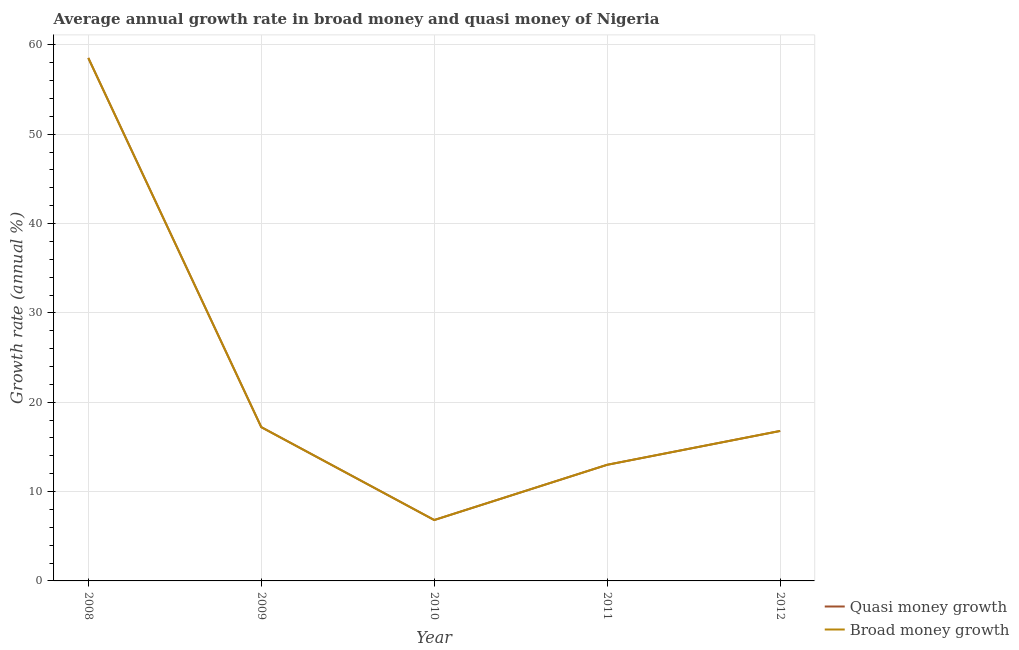How many different coloured lines are there?
Your answer should be very brief. 2. Is the number of lines equal to the number of legend labels?
Your response must be concise. Yes. What is the annual growth rate in broad money in 2008?
Ensure brevity in your answer.  58.53. Across all years, what is the maximum annual growth rate in quasi money?
Offer a terse response. 58.53. Across all years, what is the minimum annual growth rate in broad money?
Give a very brief answer. 6.82. In which year was the annual growth rate in broad money maximum?
Offer a terse response. 2008. In which year was the annual growth rate in quasi money minimum?
Offer a very short reply. 2010. What is the total annual growth rate in broad money in the graph?
Give a very brief answer. 112.35. What is the difference between the annual growth rate in quasi money in 2008 and that in 2010?
Offer a terse response. 51.72. What is the difference between the annual growth rate in quasi money in 2010 and the annual growth rate in broad money in 2009?
Make the answer very short. -10.4. What is the average annual growth rate in broad money per year?
Your response must be concise. 22.47. In the year 2008, what is the difference between the annual growth rate in broad money and annual growth rate in quasi money?
Your response must be concise. 0. What is the ratio of the annual growth rate in quasi money in 2010 to that in 2011?
Offer a very short reply. 0.52. Is the annual growth rate in broad money in 2008 less than that in 2010?
Make the answer very short. No. What is the difference between the highest and the second highest annual growth rate in quasi money?
Your answer should be very brief. 41.32. What is the difference between the highest and the lowest annual growth rate in broad money?
Provide a succinct answer. 51.72. In how many years, is the annual growth rate in broad money greater than the average annual growth rate in broad money taken over all years?
Offer a terse response. 1. Does the annual growth rate in broad money monotonically increase over the years?
Offer a terse response. No. Is the annual growth rate in quasi money strictly greater than the annual growth rate in broad money over the years?
Your answer should be compact. No. How many lines are there?
Ensure brevity in your answer.  2. What is the difference between two consecutive major ticks on the Y-axis?
Your response must be concise. 10. Does the graph contain grids?
Keep it short and to the point. Yes. Where does the legend appear in the graph?
Offer a very short reply. Bottom right. What is the title of the graph?
Make the answer very short. Average annual growth rate in broad money and quasi money of Nigeria. What is the label or title of the X-axis?
Keep it short and to the point. Year. What is the label or title of the Y-axis?
Give a very brief answer. Growth rate (annual %). What is the Growth rate (annual %) in Quasi money growth in 2008?
Your answer should be very brief. 58.53. What is the Growth rate (annual %) of Broad money growth in 2008?
Provide a succinct answer. 58.53. What is the Growth rate (annual %) in Quasi money growth in 2009?
Offer a terse response. 17.21. What is the Growth rate (annual %) of Broad money growth in 2009?
Ensure brevity in your answer.  17.21. What is the Growth rate (annual %) of Quasi money growth in 2010?
Your answer should be very brief. 6.82. What is the Growth rate (annual %) in Broad money growth in 2010?
Provide a succinct answer. 6.82. What is the Growth rate (annual %) in Quasi money growth in 2011?
Make the answer very short. 13. What is the Growth rate (annual %) in Broad money growth in 2011?
Ensure brevity in your answer.  13. What is the Growth rate (annual %) in Quasi money growth in 2012?
Offer a terse response. 16.79. What is the Growth rate (annual %) in Broad money growth in 2012?
Offer a very short reply. 16.79. Across all years, what is the maximum Growth rate (annual %) in Quasi money growth?
Give a very brief answer. 58.53. Across all years, what is the maximum Growth rate (annual %) of Broad money growth?
Ensure brevity in your answer.  58.53. Across all years, what is the minimum Growth rate (annual %) in Quasi money growth?
Ensure brevity in your answer.  6.82. Across all years, what is the minimum Growth rate (annual %) in Broad money growth?
Provide a short and direct response. 6.82. What is the total Growth rate (annual %) of Quasi money growth in the graph?
Keep it short and to the point. 112.35. What is the total Growth rate (annual %) of Broad money growth in the graph?
Provide a short and direct response. 112.35. What is the difference between the Growth rate (annual %) of Quasi money growth in 2008 and that in 2009?
Your answer should be very brief. 41.32. What is the difference between the Growth rate (annual %) in Broad money growth in 2008 and that in 2009?
Your response must be concise. 41.32. What is the difference between the Growth rate (annual %) of Quasi money growth in 2008 and that in 2010?
Your response must be concise. 51.72. What is the difference between the Growth rate (annual %) in Broad money growth in 2008 and that in 2010?
Give a very brief answer. 51.72. What is the difference between the Growth rate (annual %) in Quasi money growth in 2008 and that in 2011?
Your answer should be compact. 45.54. What is the difference between the Growth rate (annual %) in Broad money growth in 2008 and that in 2011?
Your answer should be compact. 45.54. What is the difference between the Growth rate (annual %) in Quasi money growth in 2008 and that in 2012?
Your response must be concise. 41.75. What is the difference between the Growth rate (annual %) of Broad money growth in 2008 and that in 2012?
Provide a succinct answer. 41.75. What is the difference between the Growth rate (annual %) in Quasi money growth in 2009 and that in 2010?
Offer a terse response. 10.4. What is the difference between the Growth rate (annual %) in Broad money growth in 2009 and that in 2010?
Keep it short and to the point. 10.4. What is the difference between the Growth rate (annual %) of Quasi money growth in 2009 and that in 2011?
Keep it short and to the point. 4.22. What is the difference between the Growth rate (annual %) in Broad money growth in 2009 and that in 2011?
Offer a terse response. 4.22. What is the difference between the Growth rate (annual %) in Quasi money growth in 2009 and that in 2012?
Keep it short and to the point. 0.43. What is the difference between the Growth rate (annual %) of Broad money growth in 2009 and that in 2012?
Offer a terse response. 0.43. What is the difference between the Growth rate (annual %) in Quasi money growth in 2010 and that in 2011?
Offer a terse response. -6.18. What is the difference between the Growth rate (annual %) in Broad money growth in 2010 and that in 2011?
Make the answer very short. -6.18. What is the difference between the Growth rate (annual %) of Quasi money growth in 2010 and that in 2012?
Offer a terse response. -9.97. What is the difference between the Growth rate (annual %) of Broad money growth in 2010 and that in 2012?
Give a very brief answer. -9.97. What is the difference between the Growth rate (annual %) in Quasi money growth in 2011 and that in 2012?
Your answer should be very brief. -3.79. What is the difference between the Growth rate (annual %) of Broad money growth in 2011 and that in 2012?
Provide a succinct answer. -3.79. What is the difference between the Growth rate (annual %) of Quasi money growth in 2008 and the Growth rate (annual %) of Broad money growth in 2009?
Your answer should be very brief. 41.32. What is the difference between the Growth rate (annual %) of Quasi money growth in 2008 and the Growth rate (annual %) of Broad money growth in 2010?
Keep it short and to the point. 51.72. What is the difference between the Growth rate (annual %) in Quasi money growth in 2008 and the Growth rate (annual %) in Broad money growth in 2011?
Keep it short and to the point. 45.54. What is the difference between the Growth rate (annual %) in Quasi money growth in 2008 and the Growth rate (annual %) in Broad money growth in 2012?
Make the answer very short. 41.75. What is the difference between the Growth rate (annual %) in Quasi money growth in 2009 and the Growth rate (annual %) in Broad money growth in 2010?
Offer a terse response. 10.4. What is the difference between the Growth rate (annual %) of Quasi money growth in 2009 and the Growth rate (annual %) of Broad money growth in 2011?
Your response must be concise. 4.22. What is the difference between the Growth rate (annual %) of Quasi money growth in 2009 and the Growth rate (annual %) of Broad money growth in 2012?
Offer a terse response. 0.43. What is the difference between the Growth rate (annual %) in Quasi money growth in 2010 and the Growth rate (annual %) in Broad money growth in 2011?
Give a very brief answer. -6.18. What is the difference between the Growth rate (annual %) in Quasi money growth in 2010 and the Growth rate (annual %) in Broad money growth in 2012?
Offer a very short reply. -9.97. What is the difference between the Growth rate (annual %) in Quasi money growth in 2011 and the Growth rate (annual %) in Broad money growth in 2012?
Keep it short and to the point. -3.79. What is the average Growth rate (annual %) of Quasi money growth per year?
Make the answer very short. 22.47. What is the average Growth rate (annual %) of Broad money growth per year?
Your response must be concise. 22.47. In the year 2008, what is the difference between the Growth rate (annual %) of Quasi money growth and Growth rate (annual %) of Broad money growth?
Provide a succinct answer. 0. In the year 2009, what is the difference between the Growth rate (annual %) of Quasi money growth and Growth rate (annual %) of Broad money growth?
Your response must be concise. 0. In the year 2012, what is the difference between the Growth rate (annual %) of Quasi money growth and Growth rate (annual %) of Broad money growth?
Give a very brief answer. 0. What is the ratio of the Growth rate (annual %) in Quasi money growth in 2008 to that in 2009?
Keep it short and to the point. 3.4. What is the ratio of the Growth rate (annual %) in Broad money growth in 2008 to that in 2009?
Provide a short and direct response. 3.4. What is the ratio of the Growth rate (annual %) in Quasi money growth in 2008 to that in 2010?
Keep it short and to the point. 8.59. What is the ratio of the Growth rate (annual %) in Broad money growth in 2008 to that in 2010?
Your response must be concise. 8.59. What is the ratio of the Growth rate (annual %) in Quasi money growth in 2008 to that in 2011?
Ensure brevity in your answer.  4.5. What is the ratio of the Growth rate (annual %) in Broad money growth in 2008 to that in 2011?
Your answer should be very brief. 4.5. What is the ratio of the Growth rate (annual %) of Quasi money growth in 2008 to that in 2012?
Give a very brief answer. 3.49. What is the ratio of the Growth rate (annual %) of Broad money growth in 2008 to that in 2012?
Provide a succinct answer. 3.49. What is the ratio of the Growth rate (annual %) in Quasi money growth in 2009 to that in 2010?
Offer a terse response. 2.53. What is the ratio of the Growth rate (annual %) of Broad money growth in 2009 to that in 2010?
Offer a terse response. 2.53. What is the ratio of the Growth rate (annual %) of Quasi money growth in 2009 to that in 2011?
Keep it short and to the point. 1.32. What is the ratio of the Growth rate (annual %) in Broad money growth in 2009 to that in 2011?
Offer a very short reply. 1.32. What is the ratio of the Growth rate (annual %) in Quasi money growth in 2009 to that in 2012?
Your answer should be compact. 1.03. What is the ratio of the Growth rate (annual %) of Broad money growth in 2009 to that in 2012?
Ensure brevity in your answer.  1.03. What is the ratio of the Growth rate (annual %) of Quasi money growth in 2010 to that in 2011?
Offer a terse response. 0.52. What is the ratio of the Growth rate (annual %) in Broad money growth in 2010 to that in 2011?
Offer a very short reply. 0.52. What is the ratio of the Growth rate (annual %) in Quasi money growth in 2010 to that in 2012?
Keep it short and to the point. 0.41. What is the ratio of the Growth rate (annual %) of Broad money growth in 2010 to that in 2012?
Provide a succinct answer. 0.41. What is the ratio of the Growth rate (annual %) of Quasi money growth in 2011 to that in 2012?
Provide a succinct answer. 0.77. What is the ratio of the Growth rate (annual %) of Broad money growth in 2011 to that in 2012?
Provide a succinct answer. 0.77. What is the difference between the highest and the second highest Growth rate (annual %) in Quasi money growth?
Provide a succinct answer. 41.32. What is the difference between the highest and the second highest Growth rate (annual %) of Broad money growth?
Provide a succinct answer. 41.32. What is the difference between the highest and the lowest Growth rate (annual %) in Quasi money growth?
Your response must be concise. 51.72. What is the difference between the highest and the lowest Growth rate (annual %) of Broad money growth?
Your answer should be compact. 51.72. 